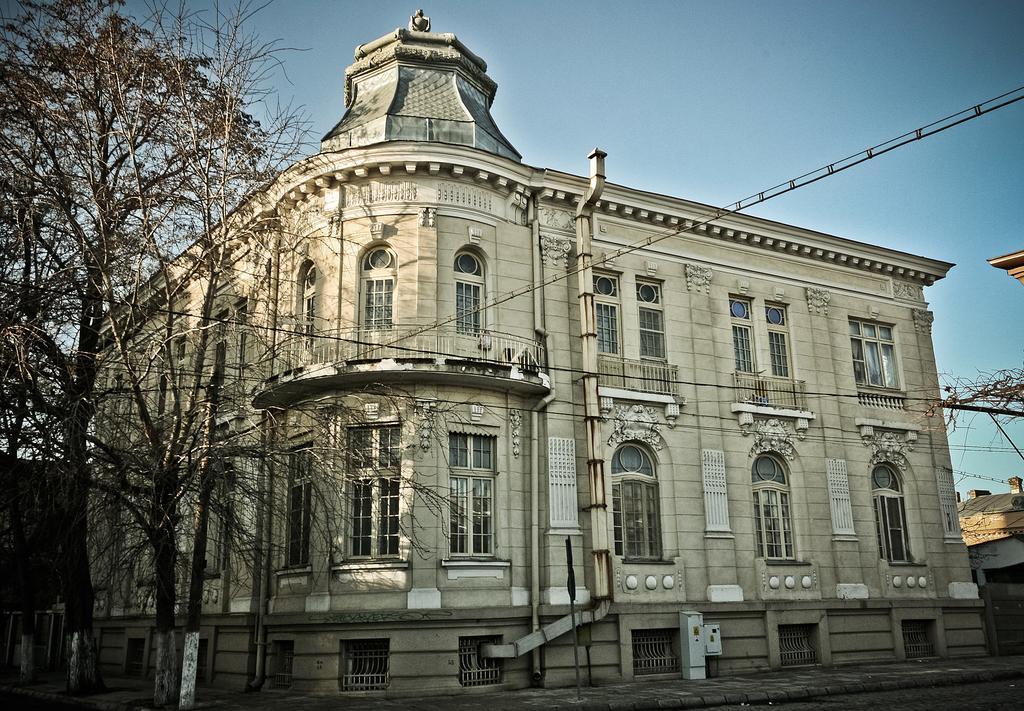Can you describe this image briefly? On the left there are trees. In the center of the picture there is a building. In the foreground it is pavement. On the right there is a tree. Sky is sunny. 